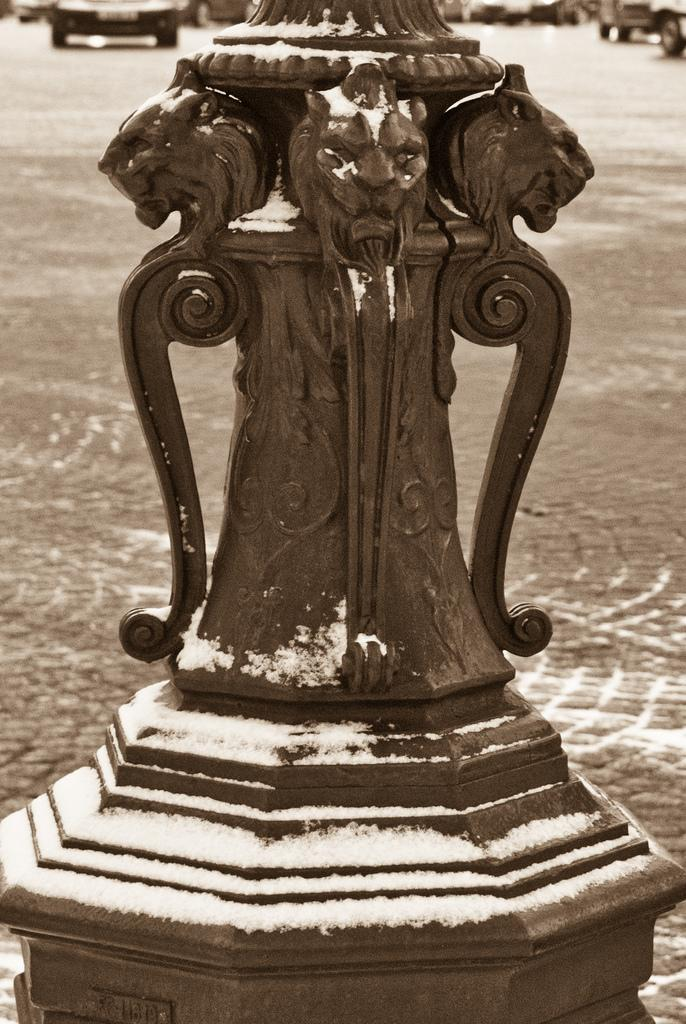What is the main object in the image? There is a metal pole in the image. What is the color of the metal pole? The metal pole is black in color. What is covering the metal pole? There is snow on the metal pole. What is the color of the snow? The snow is white in color. What can be seen in the background of the image? There is ground and vehicles visible in the background of the image. What is the value of the elbow in the image? There is no elbow present in the image, so it is not possible to determine its value. 